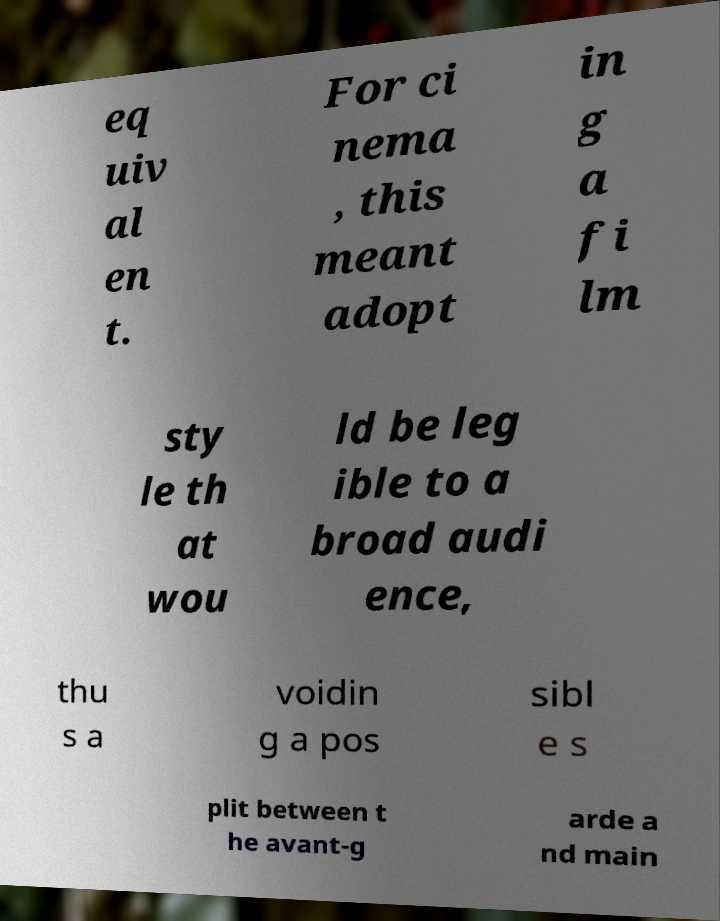Could you extract and type out the text from this image? eq uiv al en t. For ci nema , this meant adopt in g a fi lm sty le th at wou ld be leg ible to a broad audi ence, thu s a voidin g a pos sibl e s plit between t he avant-g arde a nd main 